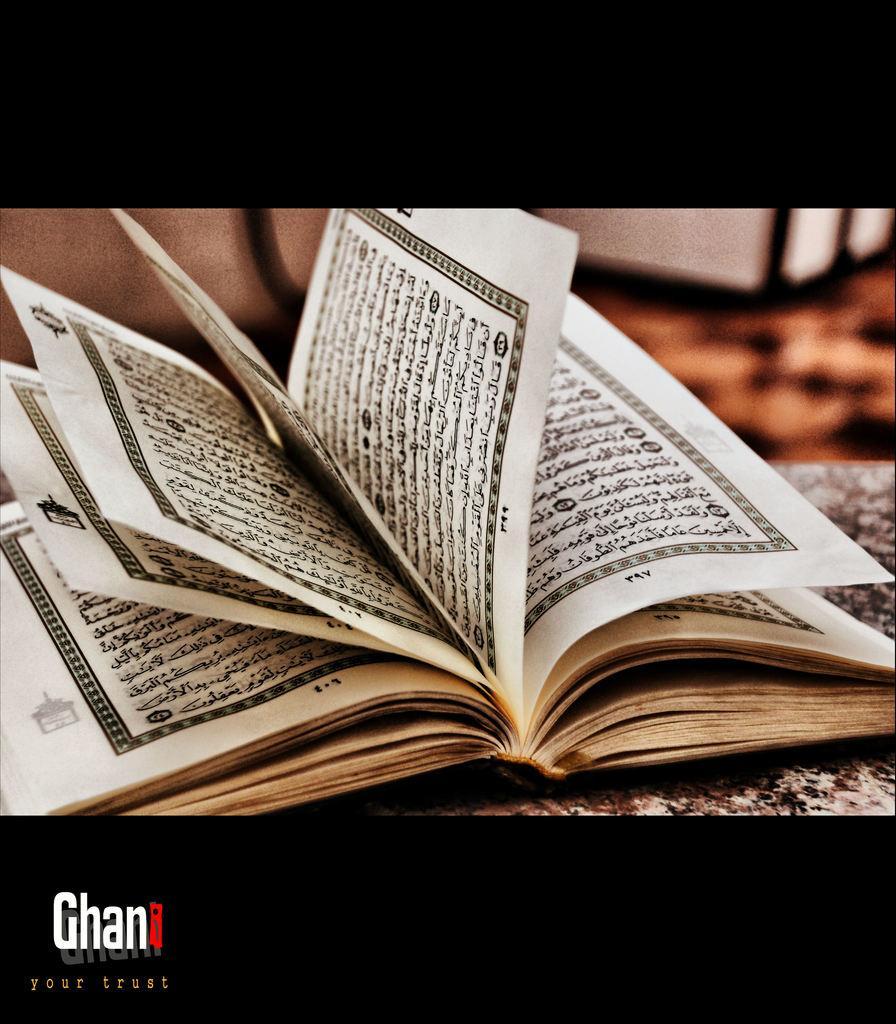How would you summarize this image in a sentence or two? Here we can see book on surface,bottom of the image we can see text. 